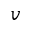Convert formula to latex. <formula><loc_0><loc_0><loc_500><loc_500>v</formula> 